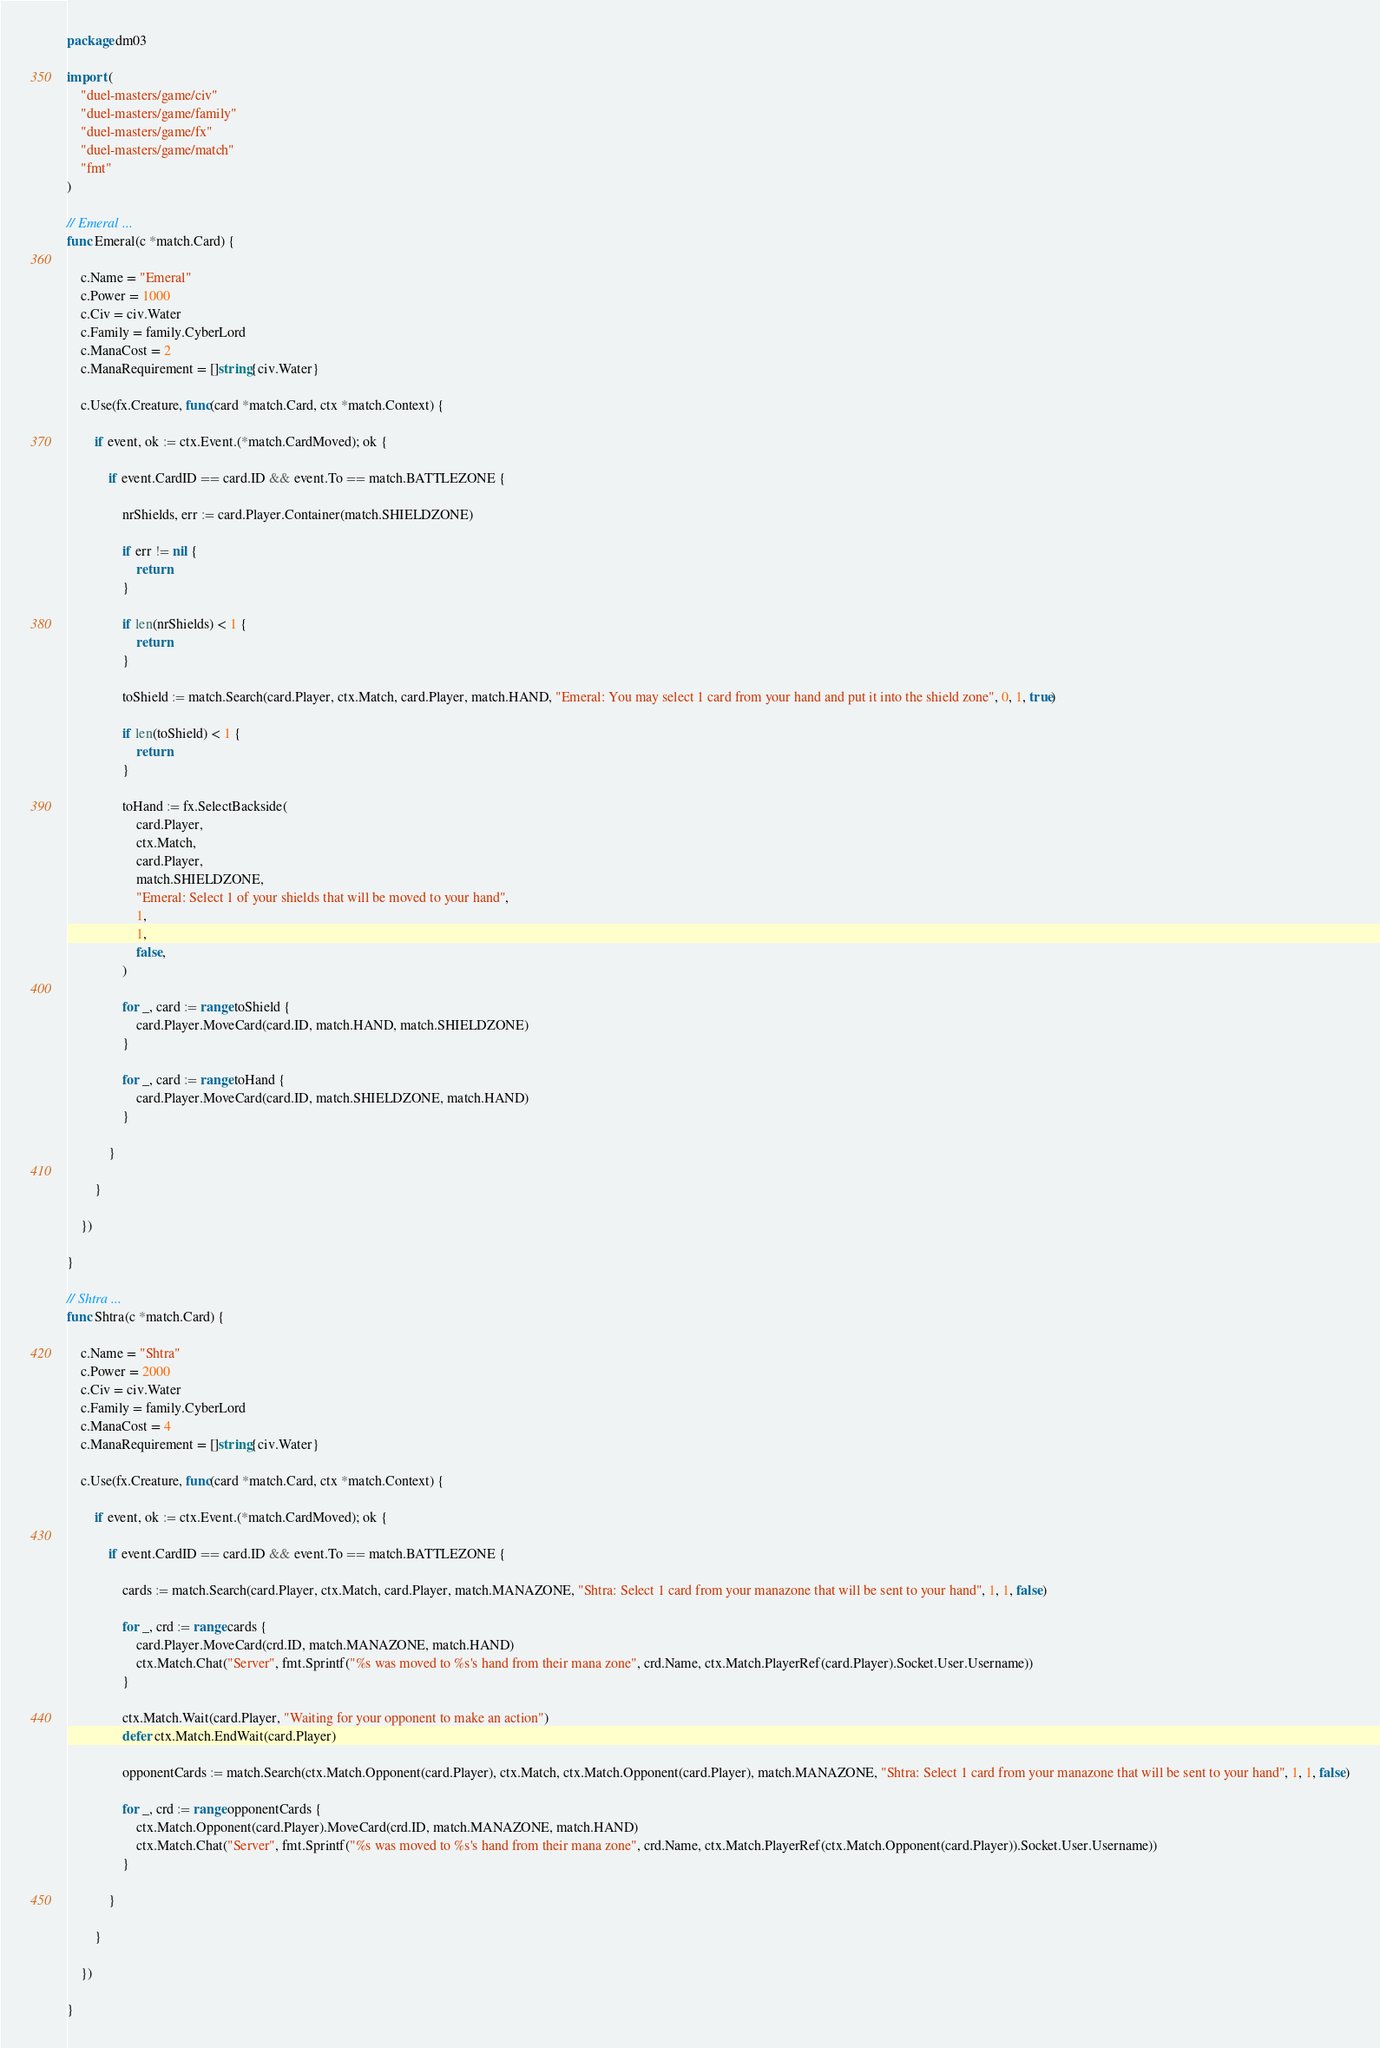<code> <loc_0><loc_0><loc_500><loc_500><_Go_>package dm03

import (
	"duel-masters/game/civ"
	"duel-masters/game/family"
	"duel-masters/game/fx"
	"duel-masters/game/match"
	"fmt"
)

// Emeral ...
func Emeral(c *match.Card) {

	c.Name = "Emeral"
	c.Power = 1000
	c.Civ = civ.Water
	c.Family = family.CyberLord
	c.ManaCost = 2
	c.ManaRequirement = []string{civ.Water}

	c.Use(fx.Creature, func(card *match.Card, ctx *match.Context) {

		if event, ok := ctx.Event.(*match.CardMoved); ok {

			if event.CardID == card.ID && event.To == match.BATTLEZONE {

				nrShields, err := card.Player.Container(match.SHIELDZONE)

				if err != nil {
					return
				}

				if len(nrShields) < 1 {
					return
				}

				toShield := match.Search(card.Player, ctx.Match, card.Player, match.HAND, "Emeral: You may select 1 card from your hand and put it into the shield zone", 0, 1, true)

				if len(toShield) < 1 {
					return
				}

				toHand := fx.SelectBackside(
					card.Player,
					ctx.Match,
					card.Player,
					match.SHIELDZONE,
					"Emeral: Select 1 of your shields that will be moved to your hand",
					1,
					1,
					false,
				)

				for _, card := range toShield {
					card.Player.MoveCard(card.ID, match.HAND, match.SHIELDZONE)
				}

				for _, card := range toHand {
					card.Player.MoveCard(card.ID, match.SHIELDZONE, match.HAND)
				}

			}

		}

	})

}

// Shtra ...
func Shtra(c *match.Card) {

	c.Name = "Shtra"
	c.Power = 2000
	c.Civ = civ.Water
	c.Family = family.CyberLord
	c.ManaCost = 4
	c.ManaRequirement = []string{civ.Water}

	c.Use(fx.Creature, func(card *match.Card, ctx *match.Context) {

		if event, ok := ctx.Event.(*match.CardMoved); ok {

			if event.CardID == card.ID && event.To == match.BATTLEZONE {

				cards := match.Search(card.Player, ctx.Match, card.Player, match.MANAZONE, "Shtra: Select 1 card from your manazone that will be sent to your hand", 1, 1, false)

				for _, crd := range cards {
					card.Player.MoveCard(crd.ID, match.MANAZONE, match.HAND)
					ctx.Match.Chat("Server", fmt.Sprintf("%s was moved to %s's hand from their mana zone", crd.Name, ctx.Match.PlayerRef(card.Player).Socket.User.Username))
				}

				ctx.Match.Wait(card.Player, "Waiting for your opponent to make an action")
				defer ctx.Match.EndWait(card.Player)

				opponentCards := match.Search(ctx.Match.Opponent(card.Player), ctx.Match, ctx.Match.Opponent(card.Player), match.MANAZONE, "Shtra: Select 1 card from your manazone that will be sent to your hand", 1, 1, false)

				for _, crd := range opponentCards {
					ctx.Match.Opponent(card.Player).MoveCard(crd.ID, match.MANAZONE, match.HAND)
					ctx.Match.Chat("Server", fmt.Sprintf("%s was moved to %s's hand from their mana zone", crd.Name, ctx.Match.PlayerRef(ctx.Match.Opponent(card.Player)).Socket.User.Username))
				}

			}

		}

	})

}</code> 